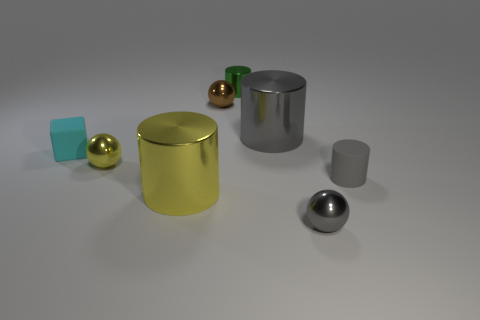Subtract all purple cylinders. Subtract all green balls. How many cylinders are left? 4 Add 1 green objects. How many objects exist? 9 Subtract all blocks. How many objects are left? 7 Subtract all tiny cyan cubes. Subtract all large brown balls. How many objects are left? 7 Add 1 spheres. How many spheres are left? 4 Add 2 rubber cubes. How many rubber cubes exist? 3 Subtract 0 gray blocks. How many objects are left? 8 